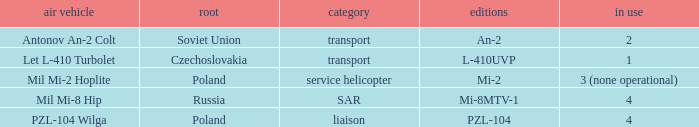Tell me the service for versions l-410uvp 1.0. 